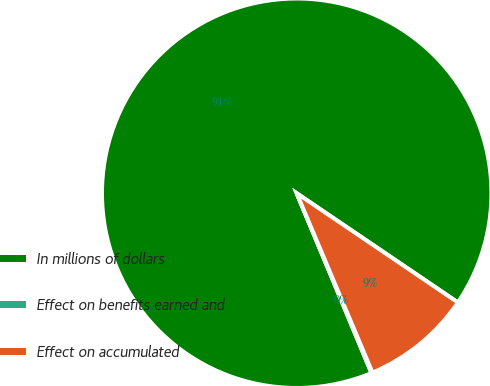<chart> <loc_0><loc_0><loc_500><loc_500><pie_chart><fcel>In millions of dollars<fcel>Effect on benefits earned and<fcel>Effect on accumulated<nl><fcel>90.75%<fcel>0.09%<fcel>9.16%<nl></chart> 